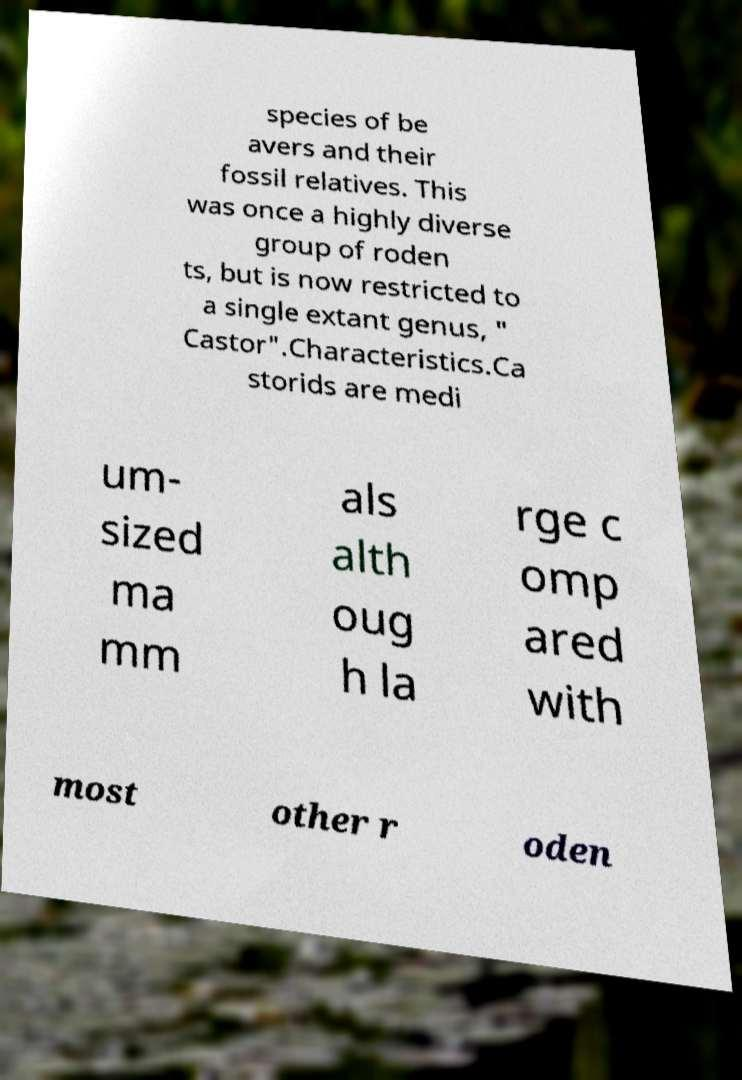I need the written content from this picture converted into text. Can you do that? species of be avers and their fossil relatives. This was once a highly diverse group of roden ts, but is now restricted to a single extant genus, " Castor".Characteristics.Ca storids are medi um- sized ma mm als alth oug h la rge c omp ared with most other r oden 